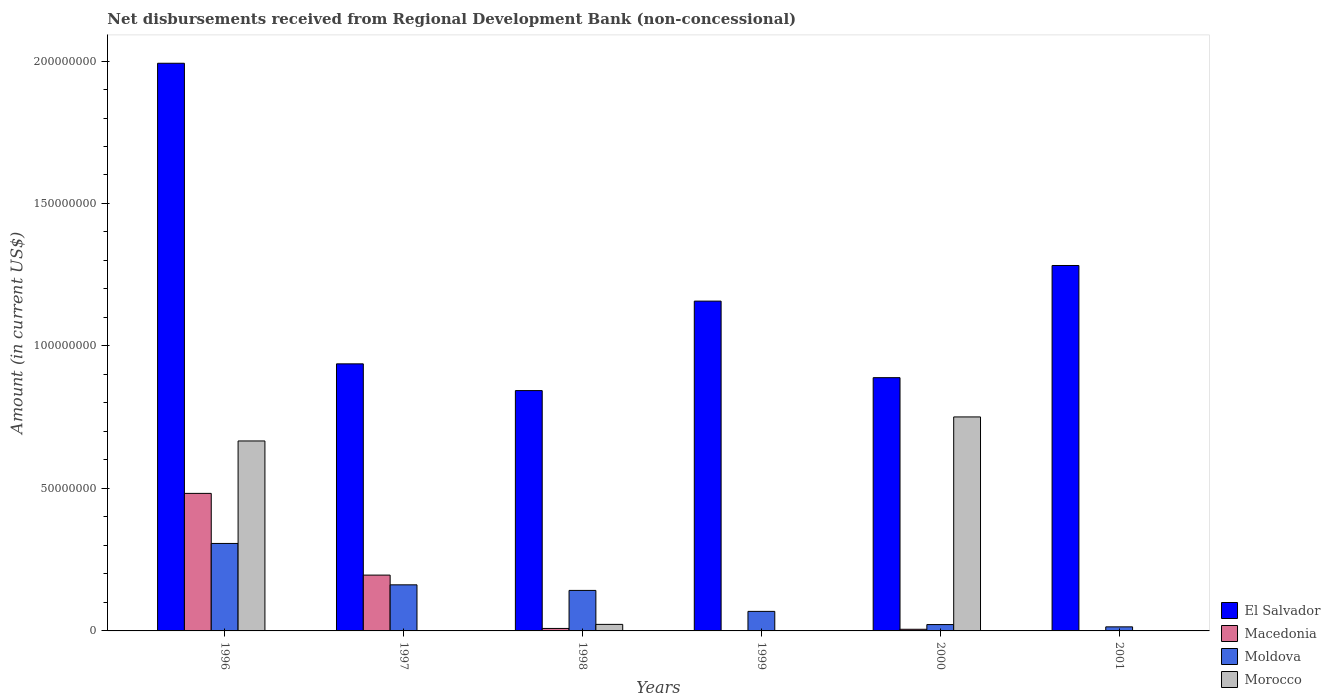How many bars are there on the 4th tick from the left?
Make the answer very short. 2. What is the amount of disbursements received from Regional Development Bank in Morocco in 1998?
Offer a terse response. 2.30e+06. Across all years, what is the maximum amount of disbursements received from Regional Development Bank in Morocco?
Your answer should be very brief. 7.51e+07. Across all years, what is the minimum amount of disbursements received from Regional Development Bank in Macedonia?
Your response must be concise. 0. What is the total amount of disbursements received from Regional Development Bank in Morocco in the graph?
Offer a terse response. 1.44e+08. What is the difference between the amount of disbursements received from Regional Development Bank in Moldova in 1997 and that in 2000?
Offer a terse response. 1.39e+07. What is the difference between the amount of disbursements received from Regional Development Bank in Macedonia in 2001 and the amount of disbursements received from Regional Development Bank in Moldova in 1999?
Ensure brevity in your answer.  -6.86e+06. What is the average amount of disbursements received from Regional Development Bank in Morocco per year?
Ensure brevity in your answer.  2.40e+07. In the year 1998, what is the difference between the amount of disbursements received from Regional Development Bank in Macedonia and amount of disbursements received from Regional Development Bank in Moldova?
Keep it short and to the point. -1.33e+07. In how many years, is the amount of disbursements received from Regional Development Bank in Macedonia greater than 20000000 US$?
Keep it short and to the point. 1. What is the ratio of the amount of disbursements received from Regional Development Bank in Macedonia in 1997 to that in 2000?
Give a very brief answer. 33.89. Is the amount of disbursements received from Regional Development Bank in El Salvador in 1999 less than that in 2000?
Provide a succinct answer. No. What is the difference between the highest and the second highest amount of disbursements received from Regional Development Bank in Macedonia?
Offer a very short reply. 2.87e+07. What is the difference between the highest and the lowest amount of disbursements received from Regional Development Bank in Macedonia?
Provide a succinct answer. 4.83e+07. Is the sum of the amount of disbursements received from Regional Development Bank in Macedonia in 1997 and 1998 greater than the maximum amount of disbursements received from Regional Development Bank in El Salvador across all years?
Make the answer very short. No. How many bars are there?
Provide a succinct answer. 19. Where does the legend appear in the graph?
Provide a succinct answer. Bottom right. How are the legend labels stacked?
Offer a very short reply. Vertical. What is the title of the graph?
Your answer should be compact. Net disbursements received from Regional Development Bank (non-concessional). Does "Burundi" appear as one of the legend labels in the graph?
Give a very brief answer. No. What is the label or title of the Y-axis?
Provide a succinct answer. Amount (in current US$). What is the Amount (in current US$) of El Salvador in 1996?
Provide a short and direct response. 1.99e+08. What is the Amount (in current US$) in Macedonia in 1996?
Your answer should be very brief. 4.83e+07. What is the Amount (in current US$) of Moldova in 1996?
Provide a succinct answer. 3.07e+07. What is the Amount (in current US$) in Morocco in 1996?
Make the answer very short. 6.67e+07. What is the Amount (in current US$) in El Salvador in 1997?
Keep it short and to the point. 9.37e+07. What is the Amount (in current US$) in Macedonia in 1997?
Make the answer very short. 1.96e+07. What is the Amount (in current US$) of Moldova in 1997?
Offer a very short reply. 1.62e+07. What is the Amount (in current US$) of El Salvador in 1998?
Make the answer very short. 8.43e+07. What is the Amount (in current US$) in Macedonia in 1998?
Keep it short and to the point. 8.67e+05. What is the Amount (in current US$) in Moldova in 1998?
Provide a short and direct response. 1.42e+07. What is the Amount (in current US$) of Morocco in 1998?
Offer a terse response. 2.30e+06. What is the Amount (in current US$) in El Salvador in 1999?
Keep it short and to the point. 1.16e+08. What is the Amount (in current US$) in Macedonia in 1999?
Your response must be concise. 0. What is the Amount (in current US$) of Moldova in 1999?
Your answer should be compact. 6.86e+06. What is the Amount (in current US$) in El Salvador in 2000?
Provide a succinct answer. 8.89e+07. What is the Amount (in current US$) of Macedonia in 2000?
Offer a very short reply. 5.78e+05. What is the Amount (in current US$) in Moldova in 2000?
Offer a very short reply. 2.23e+06. What is the Amount (in current US$) of Morocco in 2000?
Offer a terse response. 7.51e+07. What is the Amount (in current US$) of El Salvador in 2001?
Give a very brief answer. 1.28e+08. What is the Amount (in current US$) of Macedonia in 2001?
Offer a terse response. 0. What is the Amount (in current US$) in Moldova in 2001?
Your answer should be very brief. 1.43e+06. Across all years, what is the maximum Amount (in current US$) of El Salvador?
Provide a succinct answer. 1.99e+08. Across all years, what is the maximum Amount (in current US$) in Macedonia?
Ensure brevity in your answer.  4.83e+07. Across all years, what is the maximum Amount (in current US$) of Moldova?
Provide a succinct answer. 3.07e+07. Across all years, what is the maximum Amount (in current US$) of Morocco?
Your answer should be compact. 7.51e+07. Across all years, what is the minimum Amount (in current US$) of El Salvador?
Provide a short and direct response. 8.43e+07. Across all years, what is the minimum Amount (in current US$) of Moldova?
Provide a short and direct response. 1.43e+06. What is the total Amount (in current US$) of El Salvador in the graph?
Give a very brief answer. 7.10e+08. What is the total Amount (in current US$) in Macedonia in the graph?
Offer a terse response. 6.93e+07. What is the total Amount (in current US$) in Moldova in the graph?
Your response must be concise. 7.16e+07. What is the total Amount (in current US$) of Morocco in the graph?
Offer a terse response. 1.44e+08. What is the difference between the Amount (in current US$) in El Salvador in 1996 and that in 1997?
Give a very brief answer. 1.05e+08. What is the difference between the Amount (in current US$) of Macedonia in 1996 and that in 1997?
Provide a short and direct response. 2.87e+07. What is the difference between the Amount (in current US$) in Moldova in 1996 and that in 1997?
Your response must be concise. 1.45e+07. What is the difference between the Amount (in current US$) of El Salvador in 1996 and that in 1998?
Your answer should be compact. 1.15e+08. What is the difference between the Amount (in current US$) in Macedonia in 1996 and that in 1998?
Your answer should be compact. 4.74e+07. What is the difference between the Amount (in current US$) of Moldova in 1996 and that in 1998?
Offer a terse response. 1.65e+07. What is the difference between the Amount (in current US$) of Morocco in 1996 and that in 1998?
Provide a short and direct response. 6.44e+07. What is the difference between the Amount (in current US$) in El Salvador in 1996 and that in 1999?
Ensure brevity in your answer.  8.35e+07. What is the difference between the Amount (in current US$) in Moldova in 1996 and that in 1999?
Your answer should be compact. 2.38e+07. What is the difference between the Amount (in current US$) of El Salvador in 1996 and that in 2000?
Your answer should be compact. 1.10e+08. What is the difference between the Amount (in current US$) of Macedonia in 1996 and that in 2000?
Provide a succinct answer. 4.77e+07. What is the difference between the Amount (in current US$) in Moldova in 1996 and that in 2000?
Provide a short and direct response. 2.85e+07. What is the difference between the Amount (in current US$) of Morocco in 1996 and that in 2000?
Offer a very short reply. -8.43e+06. What is the difference between the Amount (in current US$) of El Salvador in 1996 and that in 2001?
Offer a very short reply. 7.10e+07. What is the difference between the Amount (in current US$) in Moldova in 1996 and that in 2001?
Your answer should be compact. 2.93e+07. What is the difference between the Amount (in current US$) of El Salvador in 1997 and that in 1998?
Ensure brevity in your answer.  9.38e+06. What is the difference between the Amount (in current US$) of Macedonia in 1997 and that in 1998?
Your answer should be very brief. 1.87e+07. What is the difference between the Amount (in current US$) of Moldova in 1997 and that in 1998?
Your answer should be very brief. 1.96e+06. What is the difference between the Amount (in current US$) in El Salvador in 1997 and that in 1999?
Provide a succinct answer. -2.20e+07. What is the difference between the Amount (in current US$) of Moldova in 1997 and that in 1999?
Provide a short and direct response. 9.32e+06. What is the difference between the Amount (in current US$) of El Salvador in 1997 and that in 2000?
Keep it short and to the point. 4.85e+06. What is the difference between the Amount (in current US$) in Macedonia in 1997 and that in 2000?
Provide a short and direct response. 1.90e+07. What is the difference between the Amount (in current US$) of Moldova in 1997 and that in 2000?
Your answer should be very brief. 1.39e+07. What is the difference between the Amount (in current US$) of El Salvador in 1997 and that in 2001?
Provide a succinct answer. -3.45e+07. What is the difference between the Amount (in current US$) in Moldova in 1997 and that in 2001?
Offer a terse response. 1.47e+07. What is the difference between the Amount (in current US$) in El Salvador in 1998 and that in 1999?
Keep it short and to the point. -3.14e+07. What is the difference between the Amount (in current US$) of Moldova in 1998 and that in 1999?
Offer a very short reply. 7.36e+06. What is the difference between the Amount (in current US$) in El Salvador in 1998 and that in 2000?
Your answer should be very brief. -4.54e+06. What is the difference between the Amount (in current US$) of Macedonia in 1998 and that in 2000?
Provide a short and direct response. 2.89e+05. What is the difference between the Amount (in current US$) in Moldova in 1998 and that in 2000?
Make the answer very short. 1.20e+07. What is the difference between the Amount (in current US$) of Morocco in 1998 and that in 2000?
Make the answer very short. -7.28e+07. What is the difference between the Amount (in current US$) of El Salvador in 1998 and that in 2001?
Make the answer very short. -4.39e+07. What is the difference between the Amount (in current US$) of Moldova in 1998 and that in 2001?
Provide a succinct answer. 1.28e+07. What is the difference between the Amount (in current US$) in El Salvador in 1999 and that in 2000?
Keep it short and to the point. 2.69e+07. What is the difference between the Amount (in current US$) of Moldova in 1999 and that in 2000?
Provide a succinct answer. 4.63e+06. What is the difference between the Amount (in current US$) in El Salvador in 1999 and that in 2001?
Keep it short and to the point. -1.25e+07. What is the difference between the Amount (in current US$) in Moldova in 1999 and that in 2001?
Ensure brevity in your answer.  5.43e+06. What is the difference between the Amount (in current US$) of El Salvador in 2000 and that in 2001?
Ensure brevity in your answer.  -3.94e+07. What is the difference between the Amount (in current US$) of Moldova in 2000 and that in 2001?
Your answer should be compact. 8.03e+05. What is the difference between the Amount (in current US$) of El Salvador in 1996 and the Amount (in current US$) of Macedonia in 1997?
Provide a short and direct response. 1.80e+08. What is the difference between the Amount (in current US$) of El Salvador in 1996 and the Amount (in current US$) of Moldova in 1997?
Offer a very short reply. 1.83e+08. What is the difference between the Amount (in current US$) of Macedonia in 1996 and the Amount (in current US$) of Moldova in 1997?
Keep it short and to the point. 3.21e+07. What is the difference between the Amount (in current US$) in El Salvador in 1996 and the Amount (in current US$) in Macedonia in 1998?
Provide a short and direct response. 1.98e+08. What is the difference between the Amount (in current US$) in El Salvador in 1996 and the Amount (in current US$) in Moldova in 1998?
Give a very brief answer. 1.85e+08. What is the difference between the Amount (in current US$) of El Salvador in 1996 and the Amount (in current US$) of Morocco in 1998?
Your answer should be very brief. 1.97e+08. What is the difference between the Amount (in current US$) in Macedonia in 1996 and the Amount (in current US$) in Moldova in 1998?
Offer a terse response. 3.41e+07. What is the difference between the Amount (in current US$) of Macedonia in 1996 and the Amount (in current US$) of Morocco in 1998?
Keep it short and to the point. 4.60e+07. What is the difference between the Amount (in current US$) in Moldova in 1996 and the Amount (in current US$) in Morocco in 1998?
Give a very brief answer. 2.84e+07. What is the difference between the Amount (in current US$) in El Salvador in 1996 and the Amount (in current US$) in Moldova in 1999?
Provide a short and direct response. 1.92e+08. What is the difference between the Amount (in current US$) in Macedonia in 1996 and the Amount (in current US$) in Moldova in 1999?
Provide a succinct answer. 4.14e+07. What is the difference between the Amount (in current US$) in El Salvador in 1996 and the Amount (in current US$) in Macedonia in 2000?
Offer a terse response. 1.99e+08. What is the difference between the Amount (in current US$) of El Salvador in 1996 and the Amount (in current US$) of Moldova in 2000?
Give a very brief answer. 1.97e+08. What is the difference between the Amount (in current US$) of El Salvador in 1996 and the Amount (in current US$) of Morocco in 2000?
Your response must be concise. 1.24e+08. What is the difference between the Amount (in current US$) of Macedonia in 1996 and the Amount (in current US$) of Moldova in 2000?
Provide a succinct answer. 4.60e+07. What is the difference between the Amount (in current US$) of Macedonia in 1996 and the Amount (in current US$) of Morocco in 2000?
Provide a short and direct response. -2.68e+07. What is the difference between the Amount (in current US$) in Moldova in 1996 and the Amount (in current US$) in Morocco in 2000?
Offer a very short reply. -4.44e+07. What is the difference between the Amount (in current US$) of El Salvador in 1996 and the Amount (in current US$) of Moldova in 2001?
Your answer should be very brief. 1.98e+08. What is the difference between the Amount (in current US$) in Macedonia in 1996 and the Amount (in current US$) in Moldova in 2001?
Provide a succinct answer. 4.68e+07. What is the difference between the Amount (in current US$) in El Salvador in 1997 and the Amount (in current US$) in Macedonia in 1998?
Offer a terse response. 9.29e+07. What is the difference between the Amount (in current US$) of El Salvador in 1997 and the Amount (in current US$) of Moldova in 1998?
Provide a succinct answer. 7.95e+07. What is the difference between the Amount (in current US$) in El Salvador in 1997 and the Amount (in current US$) in Morocco in 1998?
Make the answer very short. 9.14e+07. What is the difference between the Amount (in current US$) of Macedonia in 1997 and the Amount (in current US$) of Moldova in 1998?
Ensure brevity in your answer.  5.38e+06. What is the difference between the Amount (in current US$) in Macedonia in 1997 and the Amount (in current US$) in Morocco in 1998?
Give a very brief answer. 1.73e+07. What is the difference between the Amount (in current US$) in Moldova in 1997 and the Amount (in current US$) in Morocco in 1998?
Make the answer very short. 1.39e+07. What is the difference between the Amount (in current US$) of El Salvador in 1997 and the Amount (in current US$) of Moldova in 1999?
Your answer should be compact. 8.69e+07. What is the difference between the Amount (in current US$) in Macedonia in 1997 and the Amount (in current US$) in Moldova in 1999?
Give a very brief answer. 1.27e+07. What is the difference between the Amount (in current US$) of El Salvador in 1997 and the Amount (in current US$) of Macedonia in 2000?
Your response must be concise. 9.31e+07. What is the difference between the Amount (in current US$) of El Salvador in 1997 and the Amount (in current US$) of Moldova in 2000?
Make the answer very short. 9.15e+07. What is the difference between the Amount (in current US$) in El Salvador in 1997 and the Amount (in current US$) in Morocco in 2000?
Your answer should be compact. 1.86e+07. What is the difference between the Amount (in current US$) in Macedonia in 1997 and the Amount (in current US$) in Moldova in 2000?
Your answer should be compact. 1.74e+07. What is the difference between the Amount (in current US$) of Macedonia in 1997 and the Amount (in current US$) of Morocco in 2000?
Provide a short and direct response. -5.55e+07. What is the difference between the Amount (in current US$) of Moldova in 1997 and the Amount (in current US$) of Morocco in 2000?
Your answer should be compact. -5.89e+07. What is the difference between the Amount (in current US$) of El Salvador in 1997 and the Amount (in current US$) of Moldova in 2001?
Your answer should be very brief. 9.23e+07. What is the difference between the Amount (in current US$) in Macedonia in 1997 and the Amount (in current US$) in Moldova in 2001?
Make the answer very short. 1.82e+07. What is the difference between the Amount (in current US$) of El Salvador in 1998 and the Amount (in current US$) of Moldova in 1999?
Provide a short and direct response. 7.75e+07. What is the difference between the Amount (in current US$) in Macedonia in 1998 and the Amount (in current US$) in Moldova in 1999?
Your answer should be very brief. -5.99e+06. What is the difference between the Amount (in current US$) of El Salvador in 1998 and the Amount (in current US$) of Macedonia in 2000?
Your response must be concise. 8.38e+07. What is the difference between the Amount (in current US$) in El Salvador in 1998 and the Amount (in current US$) in Moldova in 2000?
Keep it short and to the point. 8.21e+07. What is the difference between the Amount (in current US$) in El Salvador in 1998 and the Amount (in current US$) in Morocco in 2000?
Provide a succinct answer. 9.25e+06. What is the difference between the Amount (in current US$) of Macedonia in 1998 and the Amount (in current US$) of Moldova in 2000?
Your answer should be very brief. -1.36e+06. What is the difference between the Amount (in current US$) of Macedonia in 1998 and the Amount (in current US$) of Morocco in 2000?
Your answer should be compact. -7.42e+07. What is the difference between the Amount (in current US$) of Moldova in 1998 and the Amount (in current US$) of Morocco in 2000?
Make the answer very short. -6.09e+07. What is the difference between the Amount (in current US$) in El Salvador in 1998 and the Amount (in current US$) in Moldova in 2001?
Provide a short and direct response. 8.29e+07. What is the difference between the Amount (in current US$) of Macedonia in 1998 and the Amount (in current US$) of Moldova in 2001?
Offer a terse response. -5.60e+05. What is the difference between the Amount (in current US$) in El Salvador in 1999 and the Amount (in current US$) in Macedonia in 2000?
Offer a terse response. 1.15e+08. What is the difference between the Amount (in current US$) of El Salvador in 1999 and the Amount (in current US$) of Moldova in 2000?
Provide a succinct answer. 1.14e+08. What is the difference between the Amount (in current US$) in El Salvador in 1999 and the Amount (in current US$) in Morocco in 2000?
Your answer should be compact. 4.06e+07. What is the difference between the Amount (in current US$) of Moldova in 1999 and the Amount (in current US$) of Morocco in 2000?
Your response must be concise. -6.82e+07. What is the difference between the Amount (in current US$) of El Salvador in 1999 and the Amount (in current US$) of Moldova in 2001?
Make the answer very short. 1.14e+08. What is the difference between the Amount (in current US$) of El Salvador in 2000 and the Amount (in current US$) of Moldova in 2001?
Provide a short and direct response. 8.74e+07. What is the difference between the Amount (in current US$) in Macedonia in 2000 and the Amount (in current US$) in Moldova in 2001?
Ensure brevity in your answer.  -8.49e+05. What is the average Amount (in current US$) in El Salvador per year?
Provide a short and direct response. 1.18e+08. What is the average Amount (in current US$) in Macedonia per year?
Provide a succinct answer. 1.16e+07. What is the average Amount (in current US$) of Moldova per year?
Your response must be concise. 1.19e+07. What is the average Amount (in current US$) in Morocco per year?
Your answer should be very brief. 2.40e+07. In the year 1996, what is the difference between the Amount (in current US$) in El Salvador and Amount (in current US$) in Macedonia?
Keep it short and to the point. 1.51e+08. In the year 1996, what is the difference between the Amount (in current US$) of El Salvador and Amount (in current US$) of Moldova?
Offer a terse response. 1.69e+08. In the year 1996, what is the difference between the Amount (in current US$) in El Salvador and Amount (in current US$) in Morocco?
Ensure brevity in your answer.  1.33e+08. In the year 1996, what is the difference between the Amount (in current US$) in Macedonia and Amount (in current US$) in Moldova?
Offer a terse response. 1.76e+07. In the year 1996, what is the difference between the Amount (in current US$) of Macedonia and Amount (in current US$) of Morocco?
Offer a very short reply. -1.84e+07. In the year 1996, what is the difference between the Amount (in current US$) in Moldova and Amount (in current US$) in Morocco?
Provide a short and direct response. -3.60e+07. In the year 1997, what is the difference between the Amount (in current US$) of El Salvador and Amount (in current US$) of Macedonia?
Provide a short and direct response. 7.41e+07. In the year 1997, what is the difference between the Amount (in current US$) in El Salvador and Amount (in current US$) in Moldova?
Offer a terse response. 7.76e+07. In the year 1997, what is the difference between the Amount (in current US$) in Macedonia and Amount (in current US$) in Moldova?
Ensure brevity in your answer.  3.42e+06. In the year 1998, what is the difference between the Amount (in current US$) in El Salvador and Amount (in current US$) in Macedonia?
Keep it short and to the point. 8.35e+07. In the year 1998, what is the difference between the Amount (in current US$) in El Salvador and Amount (in current US$) in Moldova?
Make the answer very short. 7.01e+07. In the year 1998, what is the difference between the Amount (in current US$) of El Salvador and Amount (in current US$) of Morocco?
Your answer should be very brief. 8.20e+07. In the year 1998, what is the difference between the Amount (in current US$) of Macedonia and Amount (in current US$) of Moldova?
Provide a succinct answer. -1.33e+07. In the year 1998, what is the difference between the Amount (in current US$) of Macedonia and Amount (in current US$) of Morocco?
Provide a short and direct response. -1.43e+06. In the year 1998, what is the difference between the Amount (in current US$) in Moldova and Amount (in current US$) in Morocco?
Give a very brief answer. 1.19e+07. In the year 1999, what is the difference between the Amount (in current US$) of El Salvador and Amount (in current US$) of Moldova?
Provide a short and direct response. 1.09e+08. In the year 2000, what is the difference between the Amount (in current US$) of El Salvador and Amount (in current US$) of Macedonia?
Make the answer very short. 8.83e+07. In the year 2000, what is the difference between the Amount (in current US$) of El Salvador and Amount (in current US$) of Moldova?
Make the answer very short. 8.66e+07. In the year 2000, what is the difference between the Amount (in current US$) of El Salvador and Amount (in current US$) of Morocco?
Offer a terse response. 1.38e+07. In the year 2000, what is the difference between the Amount (in current US$) of Macedonia and Amount (in current US$) of Moldova?
Offer a terse response. -1.65e+06. In the year 2000, what is the difference between the Amount (in current US$) in Macedonia and Amount (in current US$) in Morocco?
Your answer should be very brief. -7.45e+07. In the year 2000, what is the difference between the Amount (in current US$) of Moldova and Amount (in current US$) of Morocco?
Provide a short and direct response. -7.29e+07. In the year 2001, what is the difference between the Amount (in current US$) of El Salvador and Amount (in current US$) of Moldova?
Provide a short and direct response. 1.27e+08. What is the ratio of the Amount (in current US$) in El Salvador in 1996 to that in 1997?
Keep it short and to the point. 2.13. What is the ratio of the Amount (in current US$) in Macedonia in 1996 to that in 1997?
Your response must be concise. 2.46. What is the ratio of the Amount (in current US$) in Moldova in 1996 to that in 1997?
Keep it short and to the point. 1.9. What is the ratio of the Amount (in current US$) in El Salvador in 1996 to that in 1998?
Your response must be concise. 2.36. What is the ratio of the Amount (in current US$) in Macedonia in 1996 to that in 1998?
Provide a succinct answer. 55.67. What is the ratio of the Amount (in current US$) of Moldova in 1996 to that in 1998?
Give a very brief answer. 2.16. What is the ratio of the Amount (in current US$) of Morocco in 1996 to that in 1998?
Provide a short and direct response. 29.04. What is the ratio of the Amount (in current US$) of El Salvador in 1996 to that in 1999?
Offer a terse response. 1.72. What is the ratio of the Amount (in current US$) of Moldova in 1996 to that in 1999?
Offer a very short reply. 4.48. What is the ratio of the Amount (in current US$) in El Salvador in 1996 to that in 2000?
Ensure brevity in your answer.  2.24. What is the ratio of the Amount (in current US$) in Macedonia in 1996 to that in 2000?
Give a very brief answer. 83.51. What is the ratio of the Amount (in current US$) in Moldova in 1996 to that in 2000?
Offer a terse response. 13.77. What is the ratio of the Amount (in current US$) in Morocco in 1996 to that in 2000?
Make the answer very short. 0.89. What is the ratio of the Amount (in current US$) in El Salvador in 1996 to that in 2001?
Offer a very short reply. 1.55. What is the ratio of the Amount (in current US$) of Moldova in 1996 to that in 2001?
Provide a succinct answer. 21.51. What is the ratio of the Amount (in current US$) of El Salvador in 1997 to that in 1998?
Your response must be concise. 1.11. What is the ratio of the Amount (in current US$) in Macedonia in 1997 to that in 1998?
Make the answer very short. 22.59. What is the ratio of the Amount (in current US$) in Moldova in 1997 to that in 1998?
Provide a succinct answer. 1.14. What is the ratio of the Amount (in current US$) in El Salvador in 1997 to that in 1999?
Your response must be concise. 0.81. What is the ratio of the Amount (in current US$) in Moldova in 1997 to that in 1999?
Your answer should be very brief. 2.36. What is the ratio of the Amount (in current US$) of El Salvador in 1997 to that in 2000?
Offer a terse response. 1.05. What is the ratio of the Amount (in current US$) in Macedonia in 1997 to that in 2000?
Make the answer very short. 33.89. What is the ratio of the Amount (in current US$) in Moldova in 1997 to that in 2000?
Your answer should be compact. 7.25. What is the ratio of the Amount (in current US$) of El Salvador in 1997 to that in 2001?
Make the answer very short. 0.73. What is the ratio of the Amount (in current US$) in Moldova in 1997 to that in 2001?
Your answer should be very brief. 11.33. What is the ratio of the Amount (in current US$) of El Salvador in 1998 to that in 1999?
Offer a terse response. 0.73. What is the ratio of the Amount (in current US$) of Moldova in 1998 to that in 1999?
Your response must be concise. 2.07. What is the ratio of the Amount (in current US$) in El Salvador in 1998 to that in 2000?
Your answer should be very brief. 0.95. What is the ratio of the Amount (in current US$) in Moldova in 1998 to that in 2000?
Offer a very short reply. 6.37. What is the ratio of the Amount (in current US$) of Morocco in 1998 to that in 2000?
Offer a very short reply. 0.03. What is the ratio of the Amount (in current US$) in El Salvador in 1998 to that in 2001?
Make the answer very short. 0.66. What is the ratio of the Amount (in current US$) of Moldova in 1998 to that in 2001?
Offer a terse response. 9.96. What is the ratio of the Amount (in current US$) in El Salvador in 1999 to that in 2000?
Offer a very short reply. 1.3. What is the ratio of the Amount (in current US$) of Moldova in 1999 to that in 2000?
Your response must be concise. 3.07. What is the ratio of the Amount (in current US$) in El Salvador in 1999 to that in 2001?
Your response must be concise. 0.9. What is the ratio of the Amount (in current US$) of Moldova in 1999 to that in 2001?
Offer a terse response. 4.8. What is the ratio of the Amount (in current US$) in El Salvador in 2000 to that in 2001?
Give a very brief answer. 0.69. What is the ratio of the Amount (in current US$) in Moldova in 2000 to that in 2001?
Keep it short and to the point. 1.56. What is the difference between the highest and the second highest Amount (in current US$) of El Salvador?
Make the answer very short. 7.10e+07. What is the difference between the highest and the second highest Amount (in current US$) in Macedonia?
Offer a terse response. 2.87e+07. What is the difference between the highest and the second highest Amount (in current US$) in Moldova?
Offer a very short reply. 1.45e+07. What is the difference between the highest and the second highest Amount (in current US$) of Morocco?
Ensure brevity in your answer.  8.43e+06. What is the difference between the highest and the lowest Amount (in current US$) in El Salvador?
Your response must be concise. 1.15e+08. What is the difference between the highest and the lowest Amount (in current US$) in Macedonia?
Your answer should be very brief. 4.83e+07. What is the difference between the highest and the lowest Amount (in current US$) in Moldova?
Offer a very short reply. 2.93e+07. What is the difference between the highest and the lowest Amount (in current US$) of Morocco?
Provide a succinct answer. 7.51e+07. 